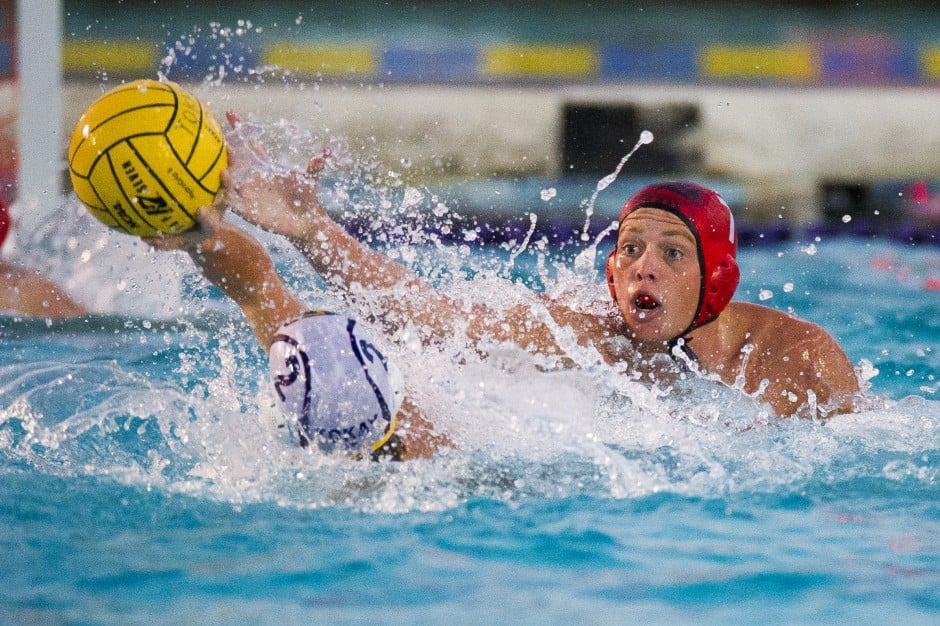Considering the trajectory of the ball and the positioning of the players, which team currently has possession, or who is more likely to gain possession? Based on the image, it appears that neither team has firm possession of the ball at this moment. The player in the red cap is stretching out their arm towards the ball, suggesting a strong attempt to intercept or gain possession. The trajectory of the ball seems to indicate that it is coming from the direction of the player in the white cap, implying their team initially had possession. However, given that the player in the red cap has their hand closer to the ball, they are likely to be the next to gain possession. The dynamics of this interaction show a competitive effort from both teams, with the player in the red cap seemingly in the more advantageous position. 